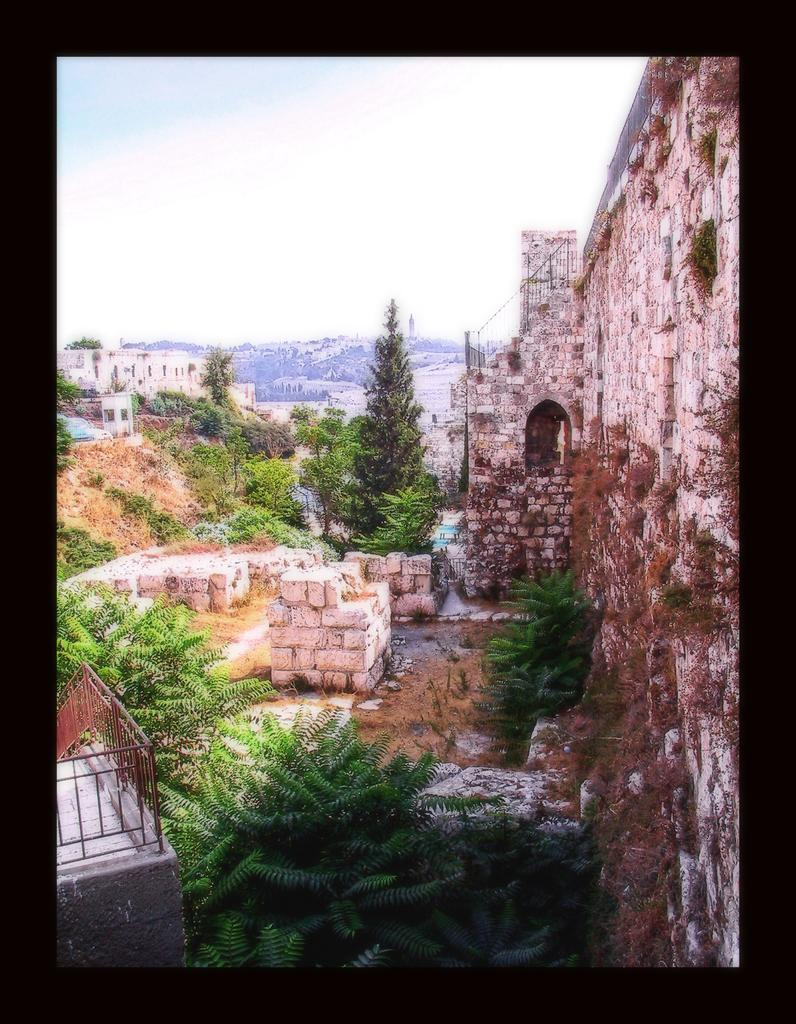What type of vegetation is present in the image? There are trees in the image. What type of structure can be seen in the image? There is a stone wall in the image. What other man-made structures are visible in the image? There are buildings in the image. What can be seen in the distance in the image? There are hills in the background of the image. What is visible above the hills in the image? The sky is visible in the background of the image. What direction is the daughter facing in the image? There is no daughter present in the image. What type of stone is the wall made of in the image? The provided facts do not specify the type of stone used in the wall. 